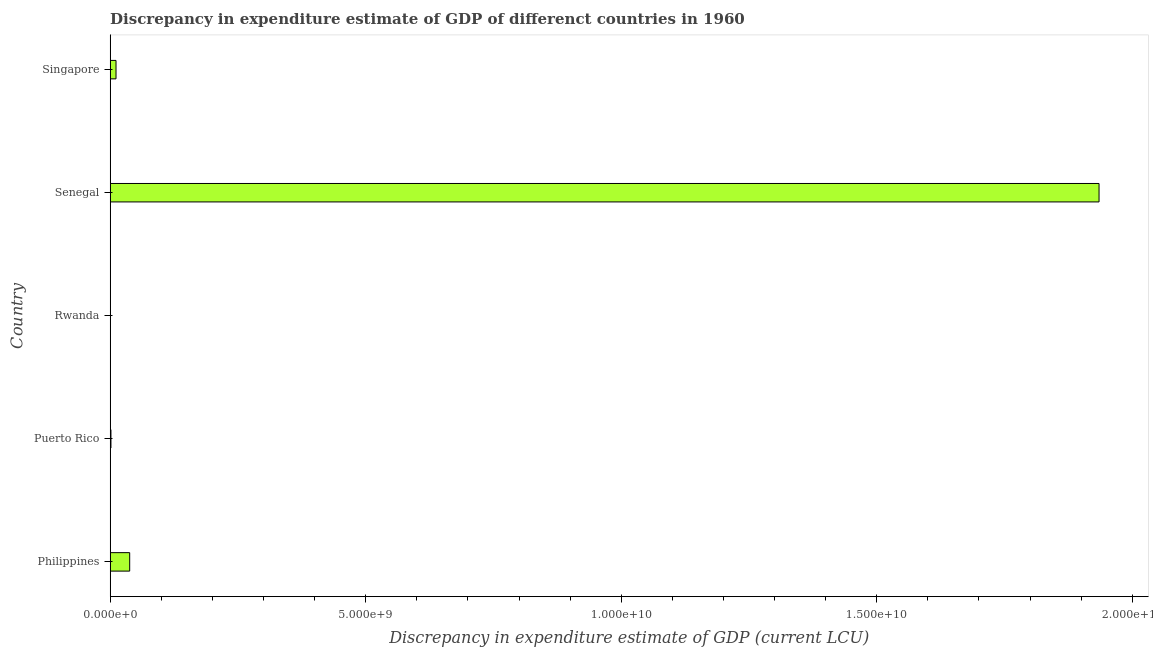Does the graph contain any zero values?
Keep it short and to the point. No. Does the graph contain grids?
Your answer should be very brief. No. What is the title of the graph?
Make the answer very short. Discrepancy in expenditure estimate of GDP of differenct countries in 1960. What is the label or title of the X-axis?
Your answer should be very brief. Discrepancy in expenditure estimate of GDP (current LCU). What is the discrepancy in expenditure estimate of gdp in Senegal?
Offer a very short reply. 1.93e+1. Across all countries, what is the maximum discrepancy in expenditure estimate of gdp?
Ensure brevity in your answer.  1.93e+1. Across all countries, what is the minimum discrepancy in expenditure estimate of gdp?
Provide a short and direct response. 4000. In which country was the discrepancy in expenditure estimate of gdp maximum?
Provide a short and direct response. Senegal. In which country was the discrepancy in expenditure estimate of gdp minimum?
Ensure brevity in your answer.  Rwanda. What is the sum of the discrepancy in expenditure estimate of gdp?
Offer a very short reply. 1.99e+1. What is the difference between the discrepancy in expenditure estimate of gdp in Philippines and Senegal?
Ensure brevity in your answer.  -1.90e+1. What is the average discrepancy in expenditure estimate of gdp per country?
Provide a succinct answer. 3.97e+09. What is the median discrepancy in expenditure estimate of gdp?
Offer a terse response. 1.15e+08. What is the ratio of the discrepancy in expenditure estimate of gdp in Puerto Rico to that in Senegal?
Keep it short and to the point. 0. Is the difference between the discrepancy in expenditure estimate of gdp in Puerto Rico and Senegal greater than the difference between any two countries?
Provide a succinct answer. No. What is the difference between the highest and the second highest discrepancy in expenditure estimate of gdp?
Make the answer very short. 1.90e+1. What is the difference between the highest and the lowest discrepancy in expenditure estimate of gdp?
Offer a very short reply. 1.93e+1. Are all the bars in the graph horizontal?
Make the answer very short. Yes. What is the difference between two consecutive major ticks on the X-axis?
Ensure brevity in your answer.  5.00e+09. What is the Discrepancy in expenditure estimate of GDP (current LCU) of Philippines?
Your response must be concise. 3.82e+08. What is the Discrepancy in expenditure estimate of GDP (current LCU) of Puerto Rico?
Ensure brevity in your answer.  1.58e+07. What is the Discrepancy in expenditure estimate of GDP (current LCU) of Rwanda?
Your answer should be very brief. 4000. What is the Discrepancy in expenditure estimate of GDP (current LCU) in Senegal?
Keep it short and to the point. 1.93e+1. What is the Discrepancy in expenditure estimate of GDP (current LCU) in Singapore?
Give a very brief answer. 1.15e+08. What is the difference between the Discrepancy in expenditure estimate of GDP (current LCU) in Philippines and Puerto Rico?
Your response must be concise. 3.66e+08. What is the difference between the Discrepancy in expenditure estimate of GDP (current LCU) in Philippines and Rwanda?
Your response must be concise. 3.82e+08. What is the difference between the Discrepancy in expenditure estimate of GDP (current LCU) in Philippines and Senegal?
Offer a very short reply. -1.90e+1. What is the difference between the Discrepancy in expenditure estimate of GDP (current LCU) in Philippines and Singapore?
Ensure brevity in your answer.  2.67e+08. What is the difference between the Discrepancy in expenditure estimate of GDP (current LCU) in Puerto Rico and Rwanda?
Offer a terse response. 1.58e+07. What is the difference between the Discrepancy in expenditure estimate of GDP (current LCU) in Puerto Rico and Senegal?
Make the answer very short. -1.93e+1. What is the difference between the Discrepancy in expenditure estimate of GDP (current LCU) in Puerto Rico and Singapore?
Offer a very short reply. -9.91e+07. What is the difference between the Discrepancy in expenditure estimate of GDP (current LCU) in Rwanda and Senegal?
Provide a short and direct response. -1.93e+1. What is the difference between the Discrepancy in expenditure estimate of GDP (current LCU) in Rwanda and Singapore?
Ensure brevity in your answer.  -1.15e+08. What is the difference between the Discrepancy in expenditure estimate of GDP (current LCU) in Senegal and Singapore?
Your response must be concise. 1.92e+1. What is the ratio of the Discrepancy in expenditure estimate of GDP (current LCU) in Philippines to that in Puerto Rico?
Keep it short and to the point. 24.19. What is the ratio of the Discrepancy in expenditure estimate of GDP (current LCU) in Philippines to that in Rwanda?
Your answer should be very brief. 9.55e+04. What is the ratio of the Discrepancy in expenditure estimate of GDP (current LCU) in Philippines to that in Senegal?
Keep it short and to the point. 0.02. What is the ratio of the Discrepancy in expenditure estimate of GDP (current LCU) in Philippines to that in Singapore?
Your response must be concise. 3.33. What is the ratio of the Discrepancy in expenditure estimate of GDP (current LCU) in Puerto Rico to that in Rwanda?
Your answer should be compact. 3950. What is the ratio of the Discrepancy in expenditure estimate of GDP (current LCU) in Puerto Rico to that in Singapore?
Provide a short and direct response. 0.14. What is the ratio of the Discrepancy in expenditure estimate of GDP (current LCU) in Rwanda to that in Senegal?
Make the answer very short. 0. What is the ratio of the Discrepancy in expenditure estimate of GDP (current LCU) in Rwanda to that in Singapore?
Your response must be concise. 0. What is the ratio of the Discrepancy in expenditure estimate of GDP (current LCU) in Senegal to that in Singapore?
Your response must be concise. 168.4. 